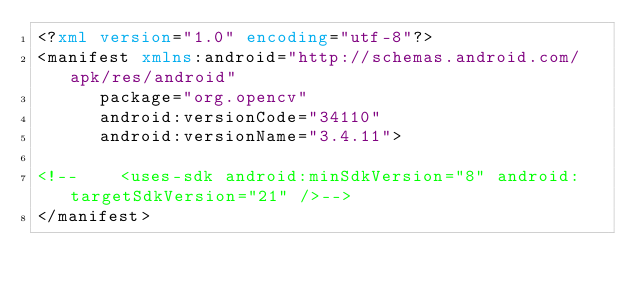<code> <loc_0><loc_0><loc_500><loc_500><_XML_><?xml version="1.0" encoding="utf-8"?>
<manifest xmlns:android="http://schemas.android.com/apk/res/android"
      package="org.opencv"
      android:versionCode="34110"
      android:versionName="3.4.11">

<!--    <uses-sdk android:minSdkVersion="8" android:targetSdkVersion="21" />-->
</manifest>
</code> 